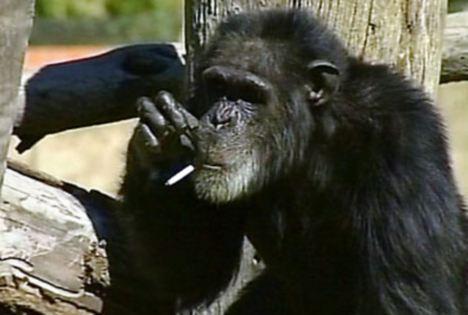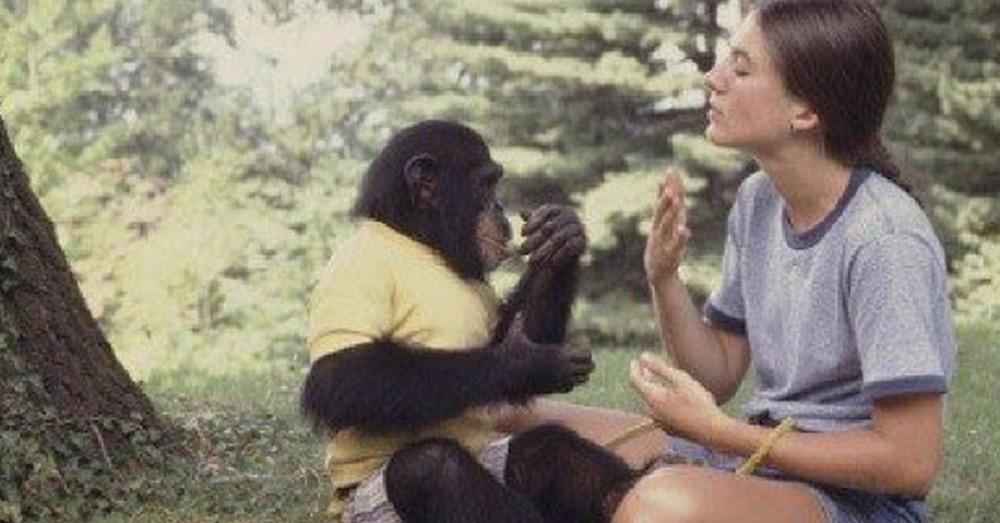The first image is the image on the left, the second image is the image on the right. Considering the images on both sides, is "There is a color photograph of a woman signing to a chimpanzee." valid? Answer yes or no. Yes. The first image is the image on the left, the second image is the image on the right. Considering the images on both sides, is "The young woman is pointing towards her eye, teaching sign language to a chimp with a heart on it's white shirt." valid? Answer yes or no. No. 